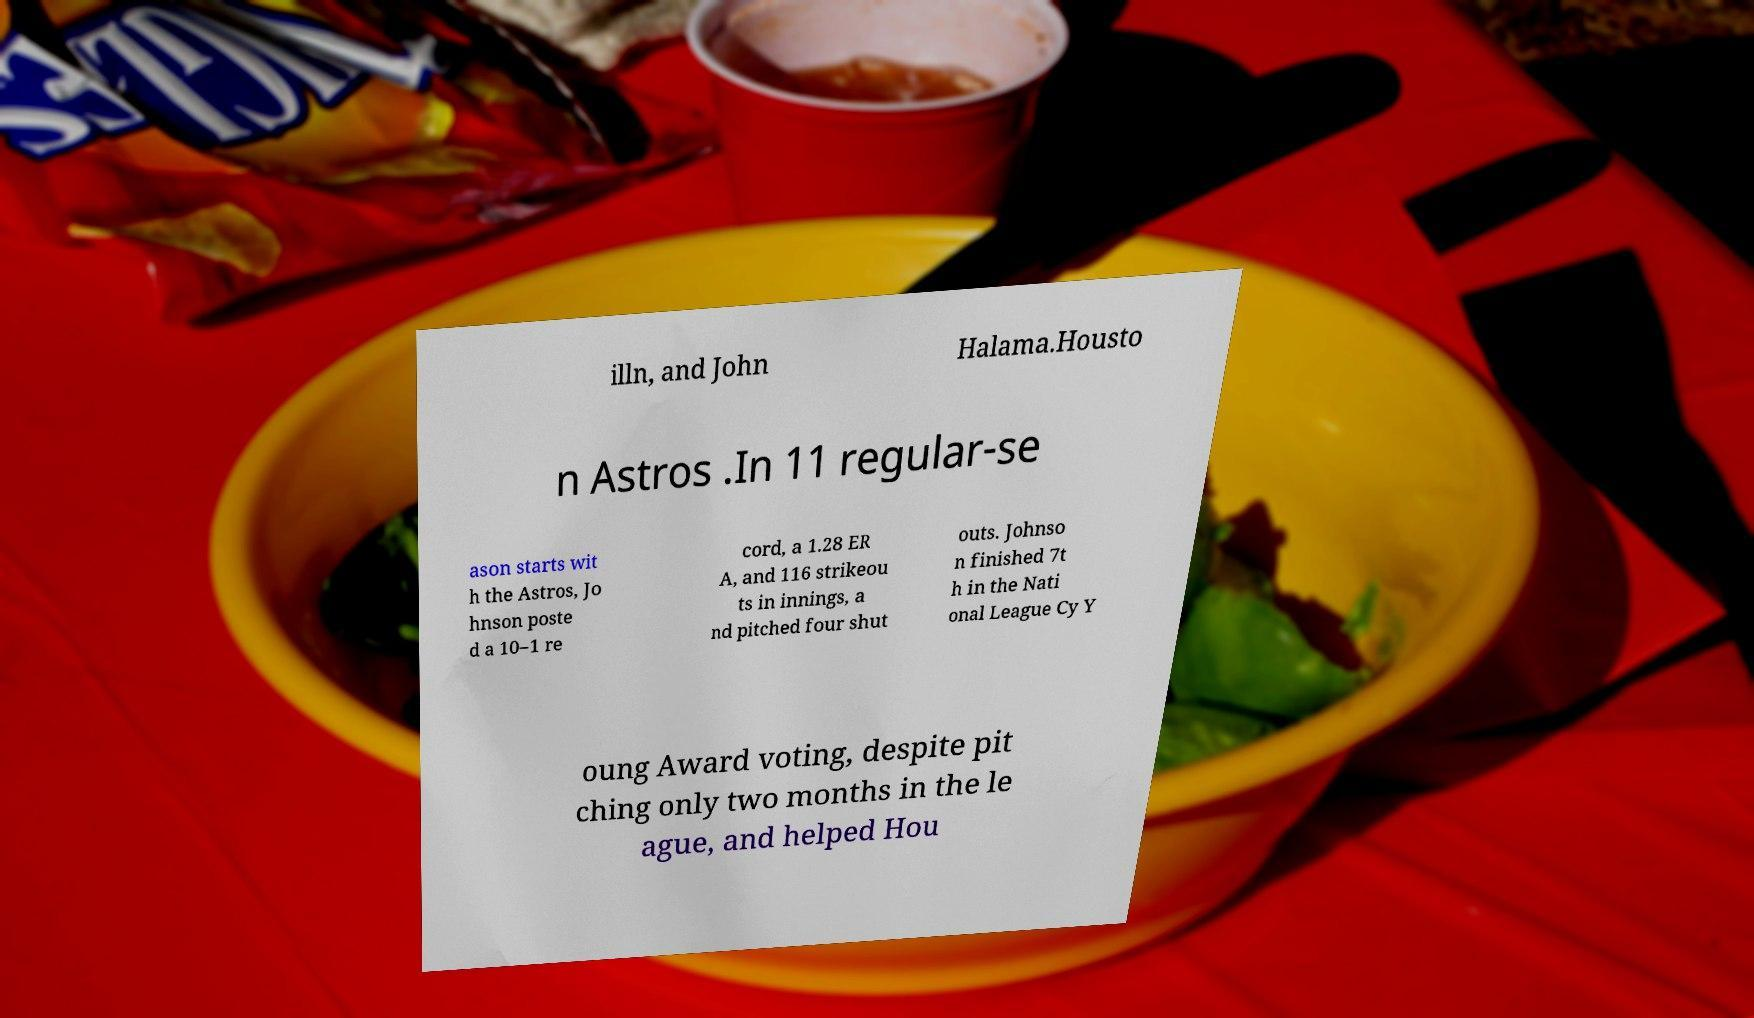Can you accurately transcribe the text from the provided image for me? illn, and John Halama.Housto n Astros .In 11 regular-se ason starts wit h the Astros, Jo hnson poste d a 10–1 re cord, a 1.28 ER A, and 116 strikeou ts in innings, a nd pitched four shut outs. Johnso n finished 7t h in the Nati onal League Cy Y oung Award voting, despite pit ching only two months in the le ague, and helped Hou 